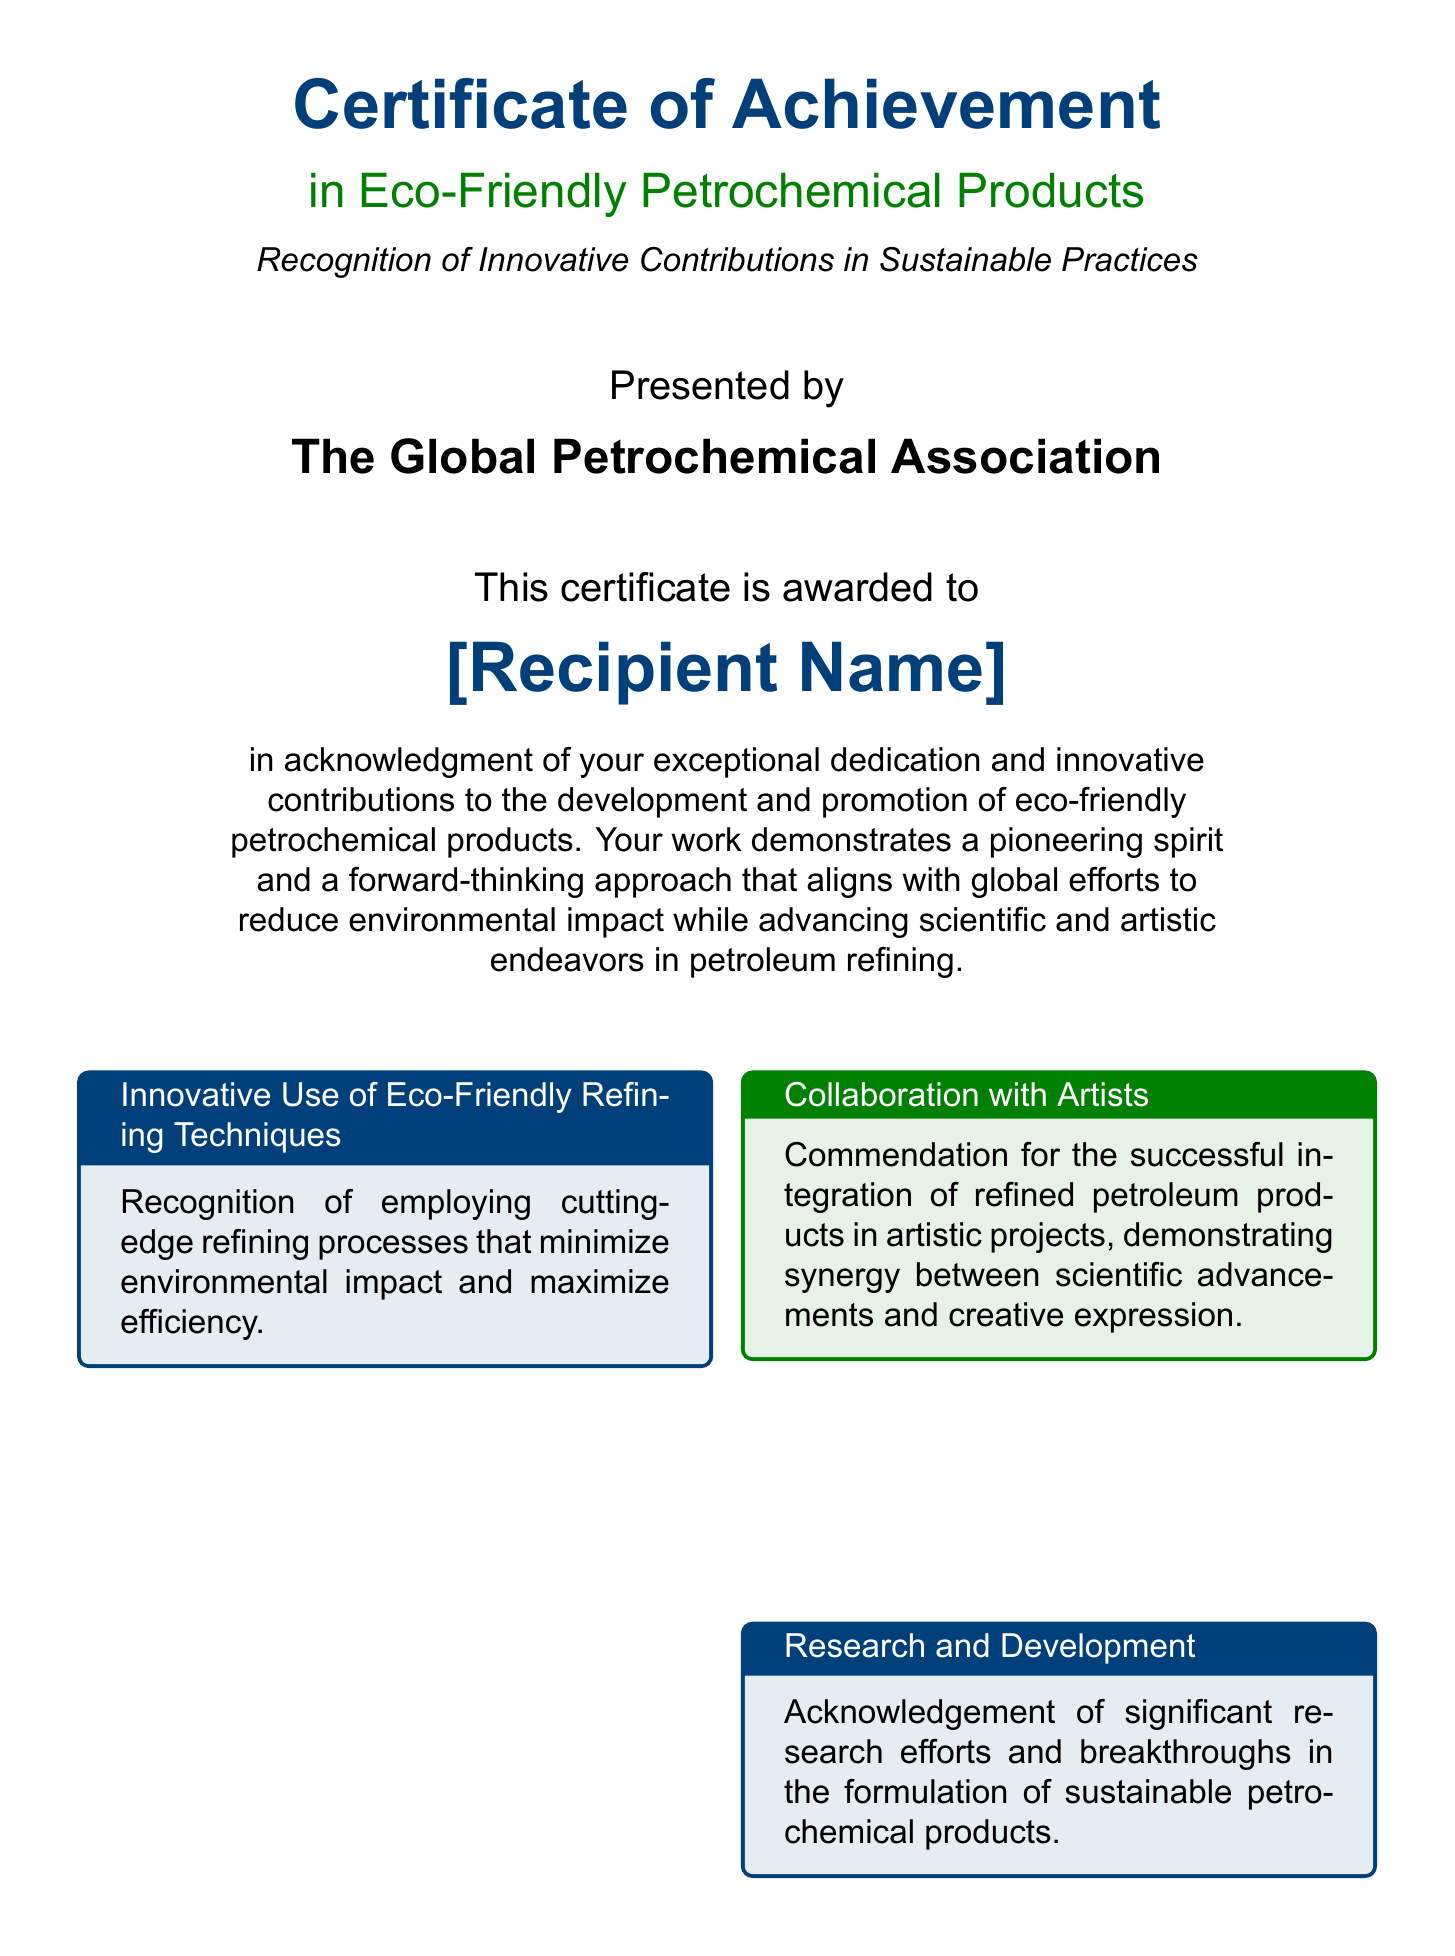What is the title of the certificate? The title of the certificate is clearly stated at the top of the document.
Answer: Certificate of Achievement Who presented the certificate? The presenting authority is noted in a specific section of the document.
Answer: The Global Petrochemical Association What is the recipient's recognition for? The specific acknowledgment of the recipient's work is mentioned in the certificate text.
Answer: Exceptional dedication and innovative contributions What color theme is used for the box about Innovative Use of Eco-Friendly Refining Techniques? The color scheme for various sections of the document can be identified by the visual styling.
Answer: Petrol blue Who is the president of The Global Petrochemical Association? The document lists the name of the person in this role.
Answer: Dr. Maria Sanchez What type of initiatives are celebrated in the Environmental Stewardship section? The document describes the focus of this section regarding environmental efforts.
Answer: Reducing carbon footprint When is the certificate awarded? The date is stated in a designated area of the document.
Answer: Date What does the Collab with Artists section commend? This section highlights a specific aspect of the recipient's work with artists.
Answer: Integration of refined petroleum products in artistic projects 